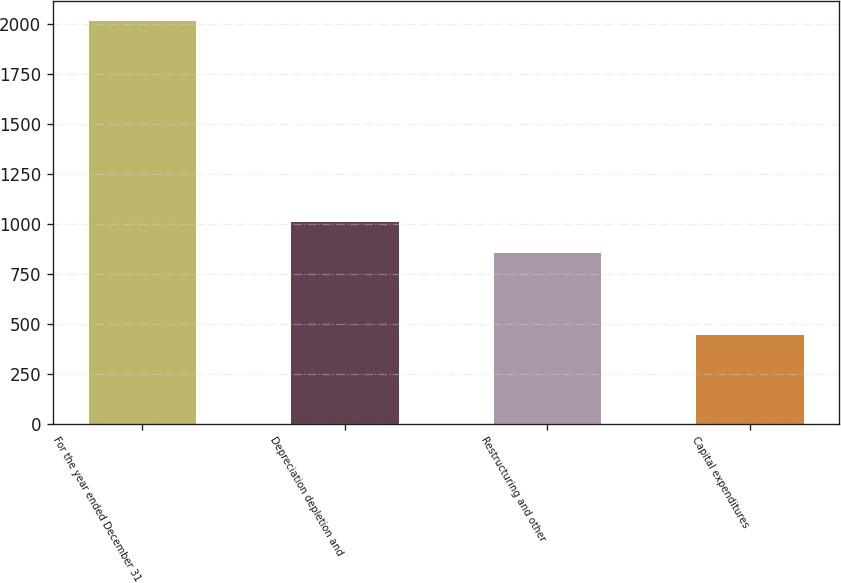Convert chart. <chart><loc_0><loc_0><loc_500><loc_500><bar_chart><fcel>For the year ended December 31<fcel>Depreciation depletion and<fcel>Restructuring and other<fcel>Capital expenditures<nl><fcel>2014<fcel>1011<fcel>854<fcel>444<nl></chart> 